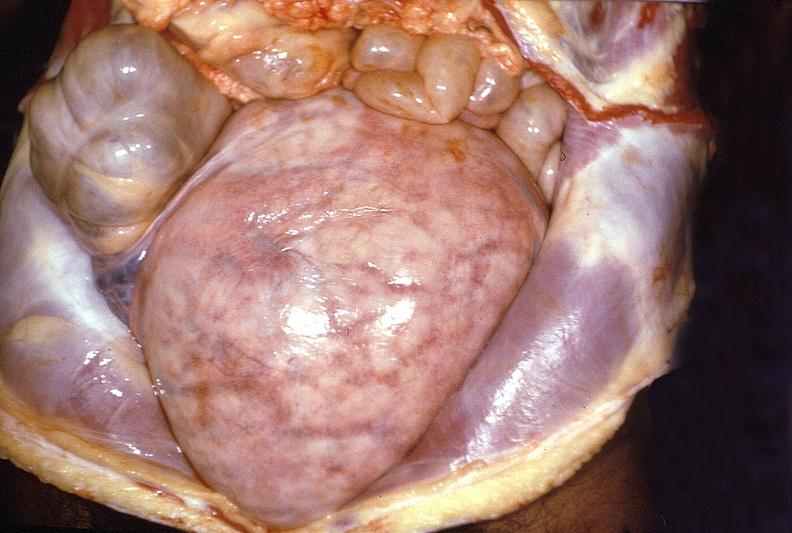does this image show gravid uterus?
Answer the question using a single word or phrase. Yes 